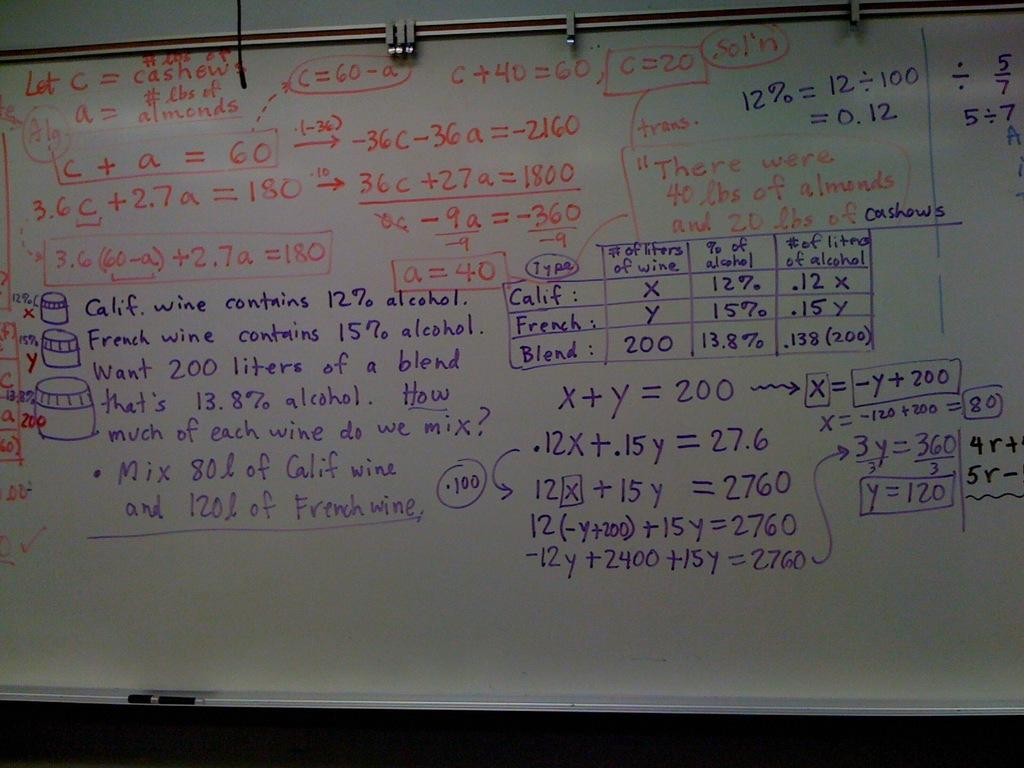Provide a one-sentence caption for the provided image. A white board that has math formulas on it, beginning with "Let C = cashew". 